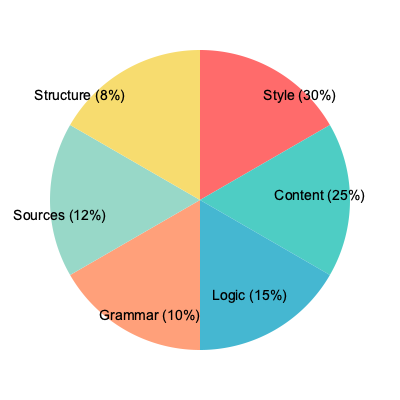In online debates critiquing an author's work, which two types of criticism combined account for more than half of the total criticism, and what is their exact combined percentage? To solve this problem, we need to follow these steps:

1. Identify the two largest segments in the pie chart:
   - Style (30%)
   - Content (25%)

2. Add these two percentages together:
   $30\% + 25\% = 55\%$

3. Verify that this combined percentage is indeed more than half (50%) of the total:
   $55\% > 50\%$

4. Check if any other combination of two segments would exceed 55%:
   - The next largest segment is Logic at 15%, which combined with Style (30%) would be 45%, less than 55%.
   - No other combination of two segments would exceed 55%.

Therefore, Style and Content criticism types combined account for more than half of the total criticism, with an exact combined percentage of 55%.
Answer: Style and Content, 55% 